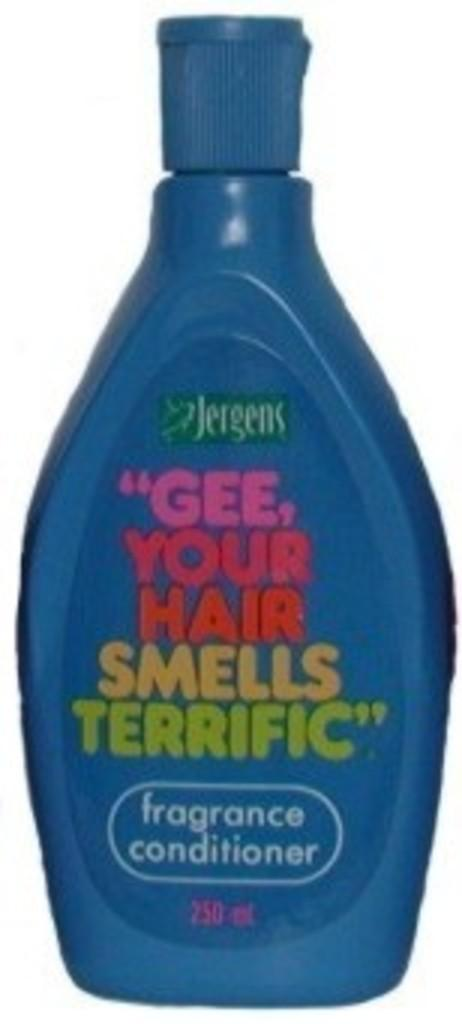<image>
Provide a brief description of the given image. A blue bottles of fragrance conditioner from Jergens. 